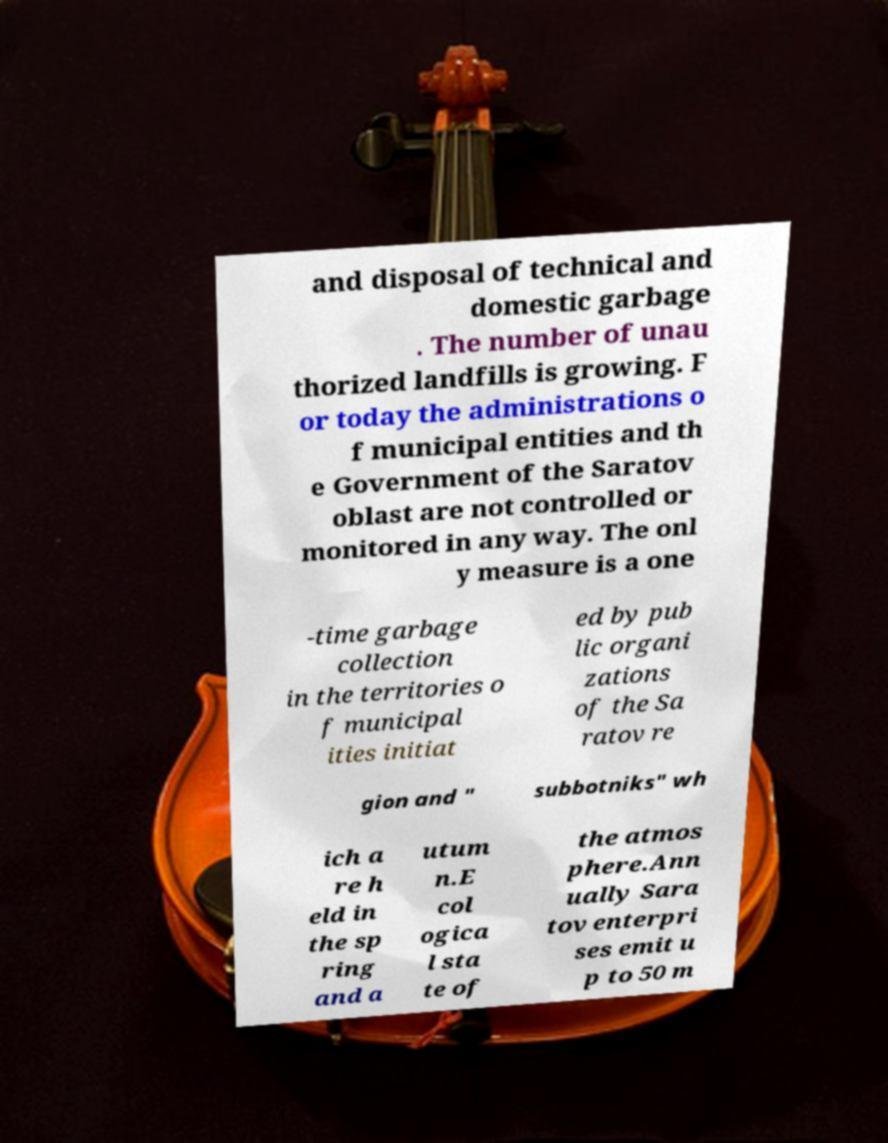I need the written content from this picture converted into text. Can you do that? and disposal of technical and domestic garbage . The number of unau thorized landfills is growing. F or today the administrations o f municipal entities and th e Government of the Saratov oblast are not controlled or monitored in any way. The onl y measure is a one -time garbage collection in the territories o f municipal ities initiat ed by pub lic organi zations of the Sa ratov re gion and " subbotniks" wh ich a re h eld in the sp ring and a utum n.E col ogica l sta te of the atmos phere.Ann ually Sara tov enterpri ses emit u p to 50 m 